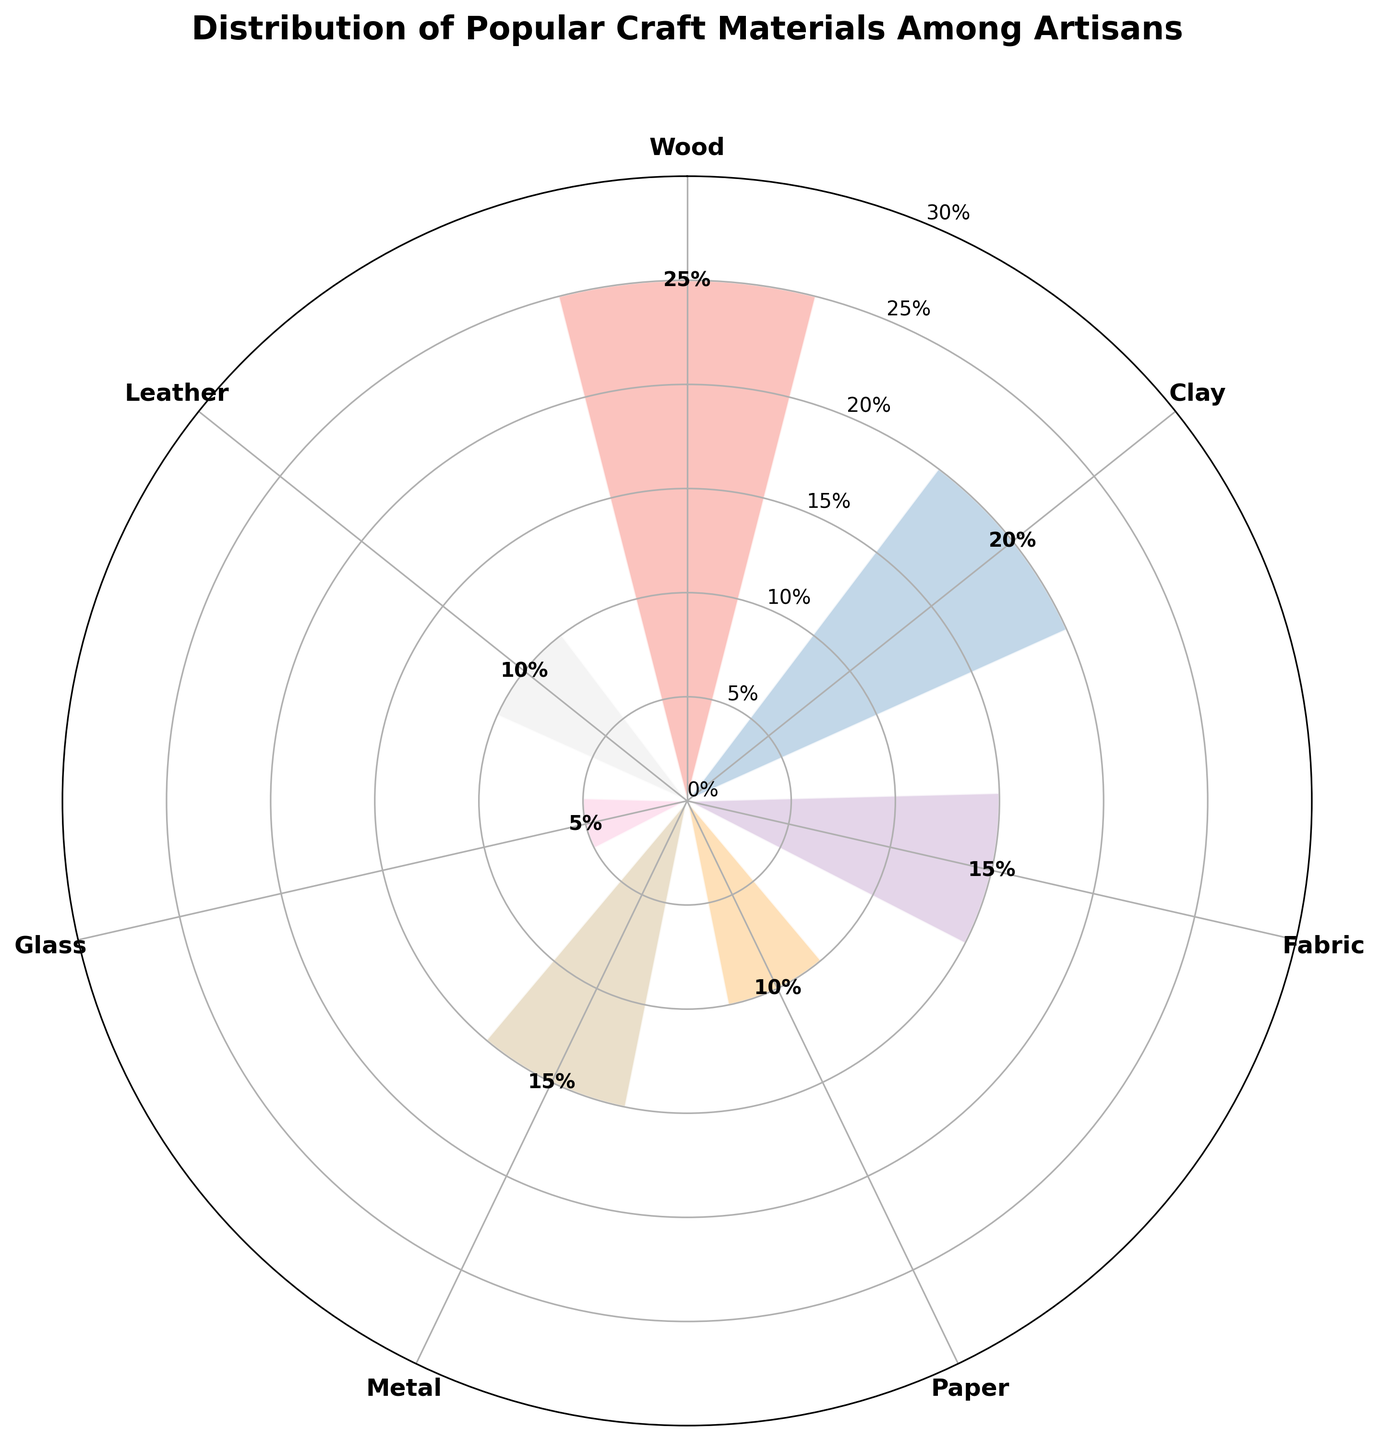What's the most frequently used craft material among artisans? The figure shows different materials along with their percentages. The largest percentage corresponds to the most frequently used material, which is Wood at 25%.
Answer: Wood Which material is used less frequently, glass or fabric? By comparing the percentages on the rose chart, Glass has a percentage of 5%, while Fabric has a percentage of 15%. Therefore, Glass is used less frequently.
Answer: Glass What is the combined percentage of artisans using paper and leather? The percentage for Paper is 10% and for Leather it is also 10%. Adding these percentages gives 10% + 10% = 20%.
Answer: 20% Which materials have an equal distribution percentage? The rose chart shows that both Fabric and Metal each have a percentage of 15%.
Answer: Fabric and Metal How much more popular is wood compared to clay? The percentage for Wood is 25% and for Clay it is 20%. The difference is 25% - 20% = 5%.
Answer: 5% What’s the least used material and its percentage? The least used material can be identified from the smallest segment of the rose chart, which is Glass at 5%.
Answer: Glass, 5% How many materials have a percentage above 10%? The materials with percentages above 10% are Wood (25%), Clay (20%), Fabric (15%), and Metal (15%). That's a total of 4 materials.
Answer: 4 Is the percentage of artisans using fabric greater than the percentage of those using glass and leather combined? The percentage for Fabric is 15%. The combined percentage for Glass (5%) and Leather (10%) is 5% + 10% = 15%. The percentages are equal.
Answer: No What is the average percentage of artisans using the listed materials? To find the average, sum up all the percentages: 25% + 20% + 15% + 10% + 15% + 5% + 10% = 100%. Divide by the number of materials, which is 7. The average is 100% / 7 ≈ 14.29%.
Answer: ~14.29% Which material has the second highest percentage among artisans? From the charts, the highest percentage is Wood at 25%, and the second highest is Clay at 20%.
Answer: Clay 